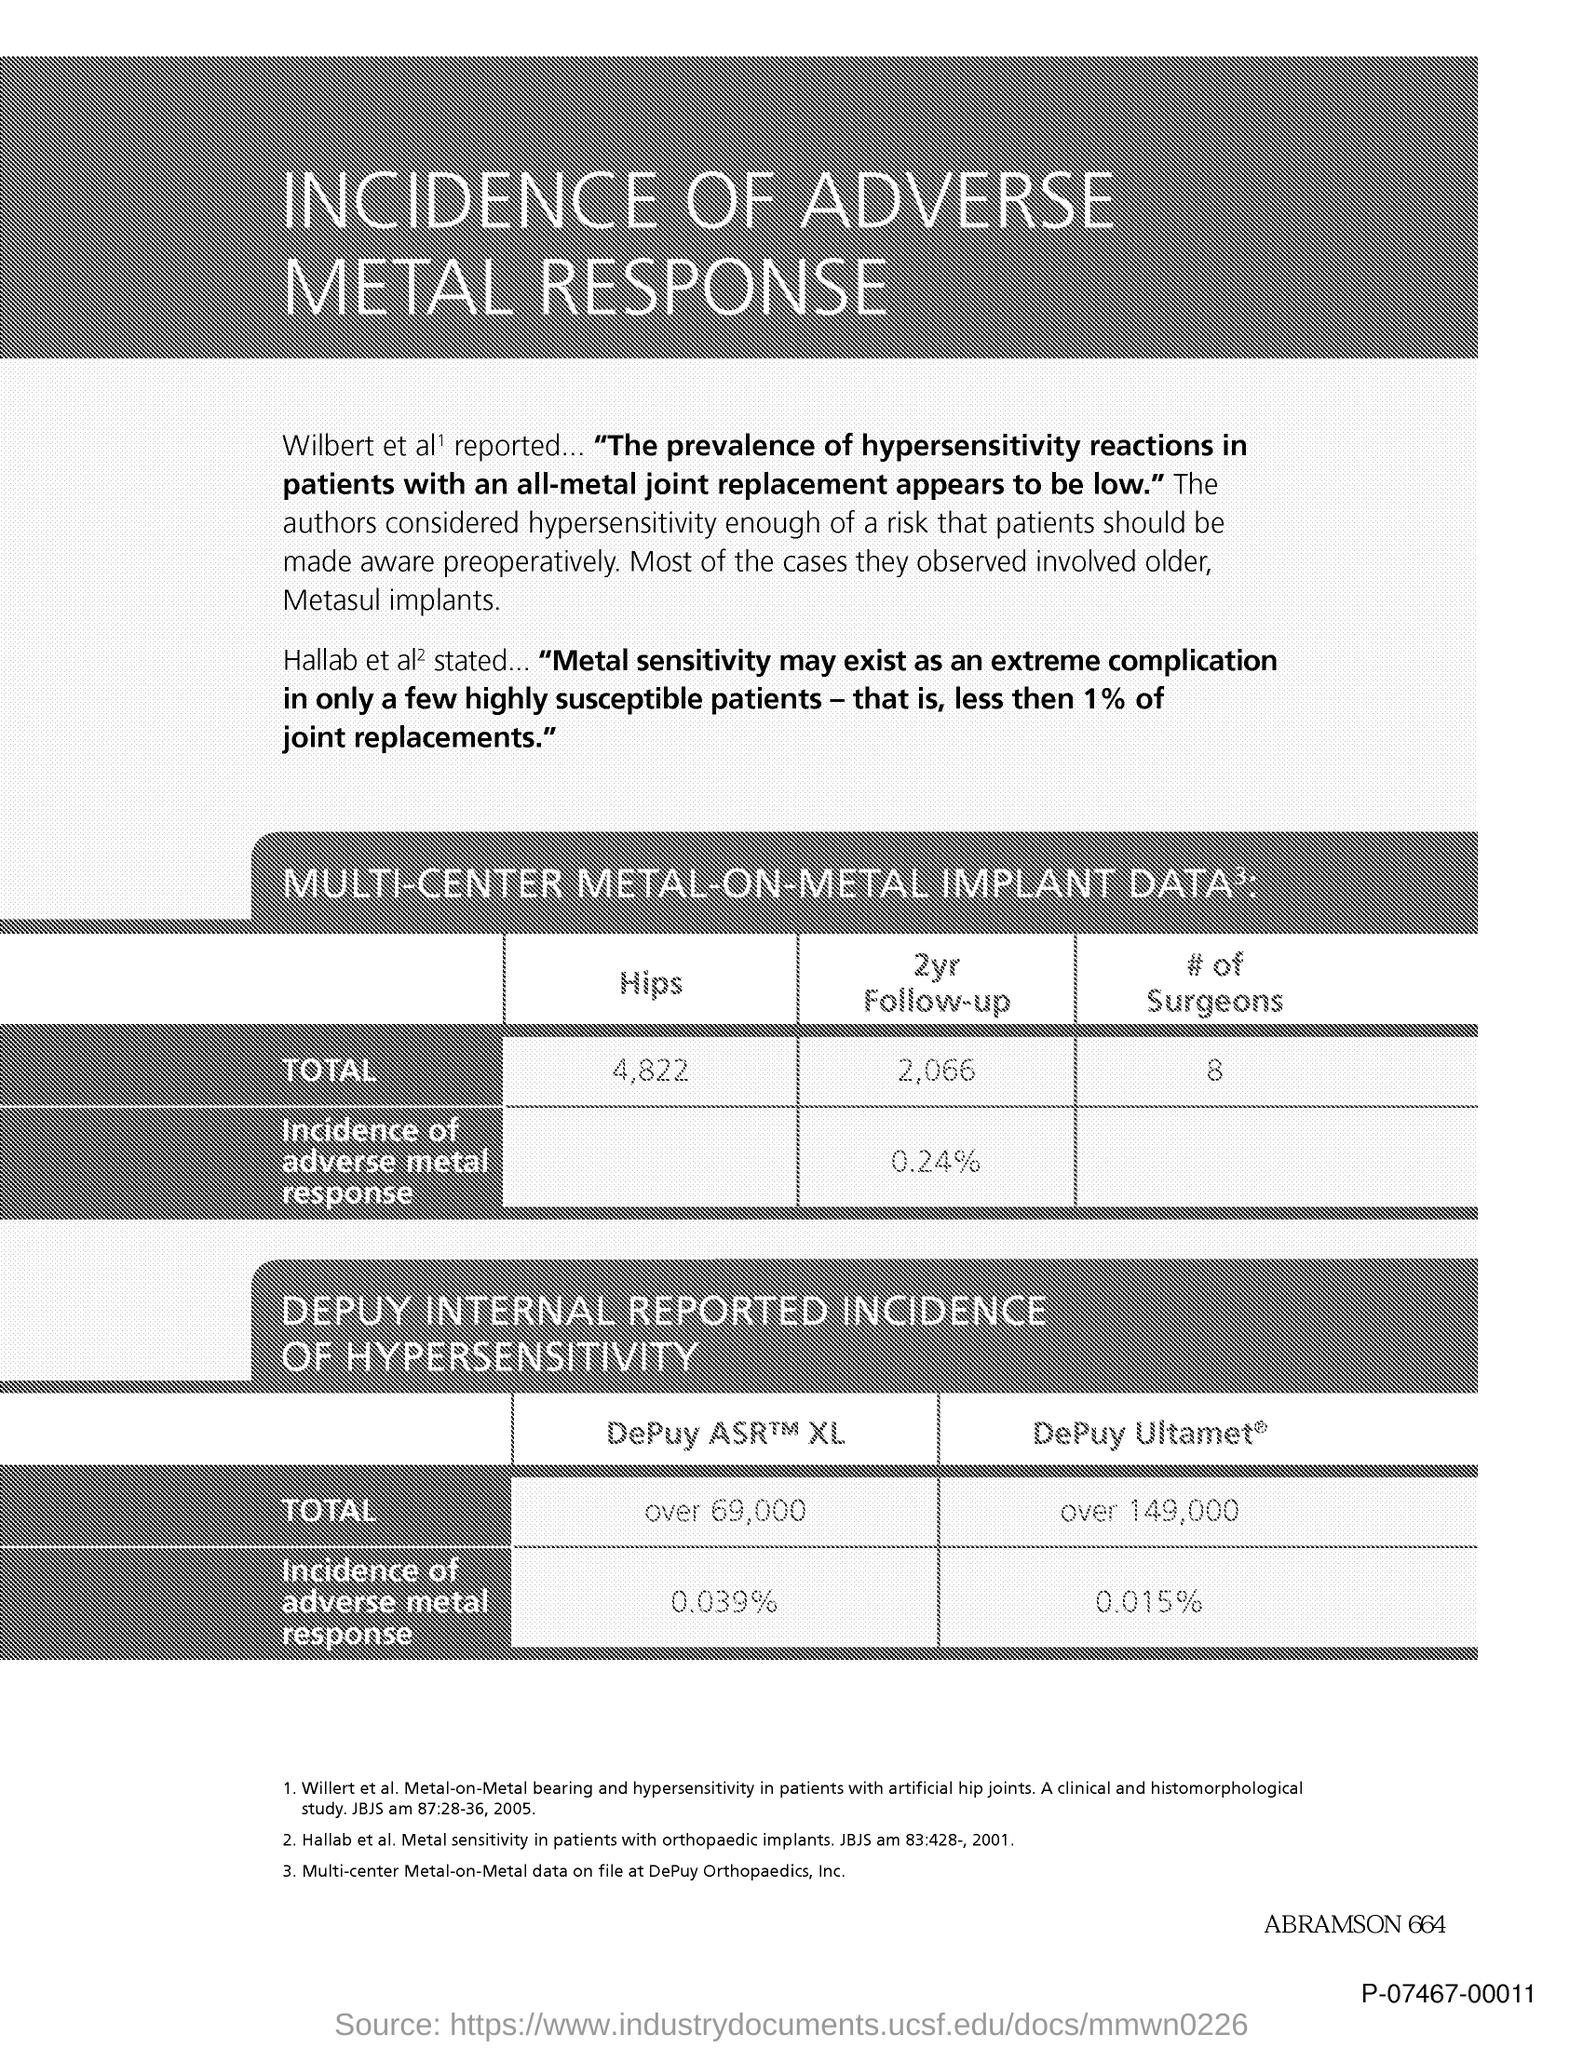What is the title of the document?
Make the answer very short. Incidence of adverse metal response. What is the total number of hips?
Your answer should be very brief. 4,822. 